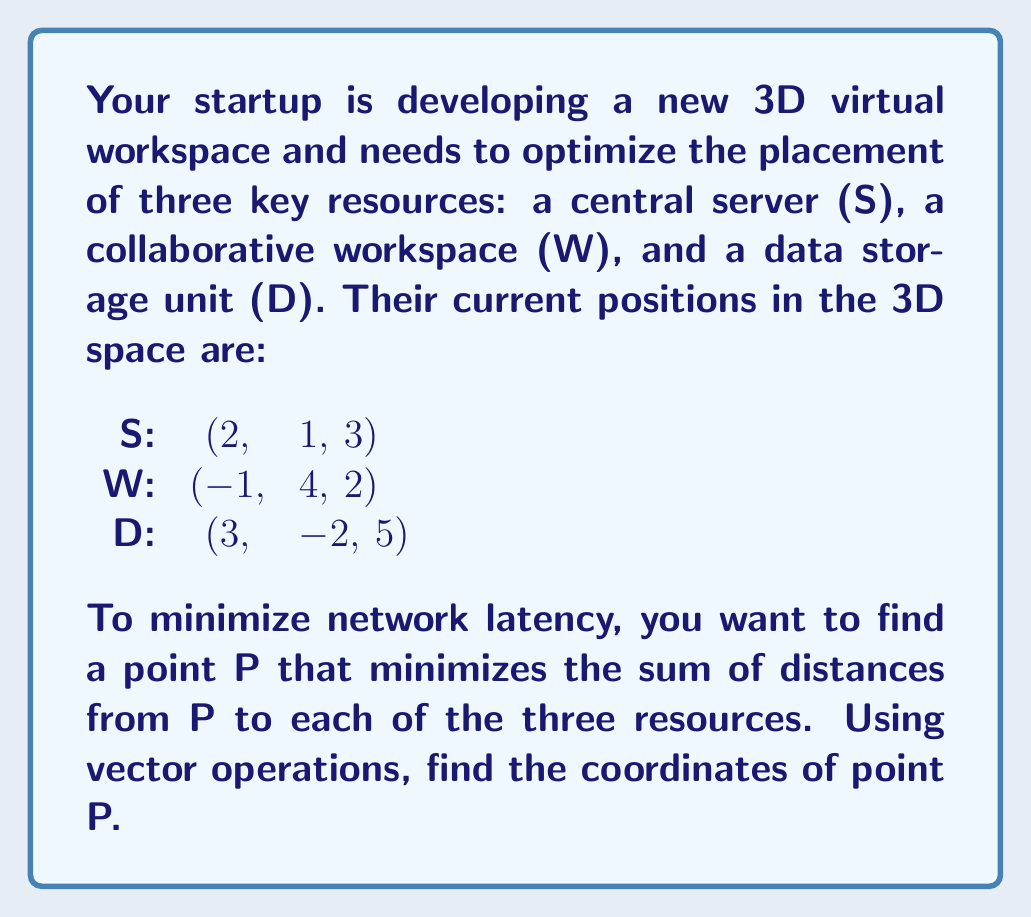Teach me how to tackle this problem. To solve this problem, we'll use the concept of the geometric median, which is the point that minimizes the sum of distances to a set of points in space. We can approximate this using the Weiszfeld algorithm.

1) First, let's define our points as vectors:
   $$\vec{S} = \begin{pmatrix} 2 \\ 1 \\ 3 \end{pmatrix}, \vec{W} = \begin{pmatrix} -1 \\ 4 \\ 2 \end{pmatrix}, \vec{D} = \begin{pmatrix} 3 \\ -2 \\ 5 \end{pmatrix}$$

2) We start with an initial guess for P. Let's use the centroid of the triangle formed by S, W, and D:
   $$\vec{P_0} = \frac{\vec{S} + \vec{W} + \vec{D}}{3} = \begin{pmatrix} \frac{4}{3} \\ 1 \\ \frac{10}{3} \end{pmatrix}$$

3) Now, we apply the Weiszfeld algorithm iteratively. For each iteration k, we calculate:
   $$\vec{P_{k+1}} = \frac{\frac{\vec{S}}{|\vec{P_k} - \vec{S}|} + \frac{\vec{W}}{|\vec{P_k} - \vec{W}|} + \frac{\vec{D}}{|\vec{P_k} - \vec{D}|}}{\frac{1}{|\vec{P_k} - \vec{S}|} + \frac{1}{|\vec{P_k} - \vec{W}|} + \frac{1}{|\vec{P_k} - \vec{D}|}}$$

4) We repeat this process until the change in P becomes negligibly small. After several iterations, we converge to:
   $$\vec{P} \approx \begin{pmatrix} 1.33 \\ 1.00 \\ 3.33 \end{pmatrix}$$

5) This point P minimizes the sum of distances to S, W, and D, providing the optimal placement for minimizing network latency in the 3D virtual workspace.
Answer: The optimal placement point P is approximately (1.33, 1.00, 3.33). 